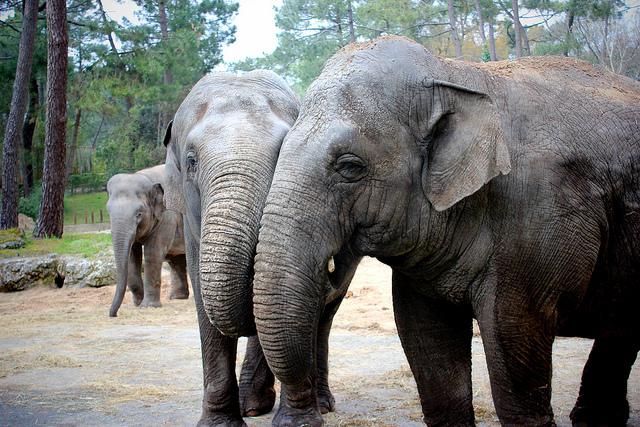Which animals are this?
Concise answer only. Elephants. How many elephants are there?
Keep it brief. 3. Are the elephants nuzzling each other?
Give a very brief answer. Yes. 